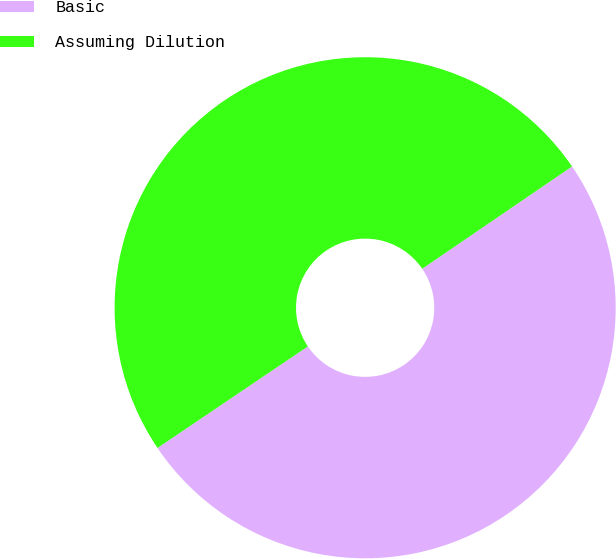Convert chart. <chart><loc_0><loc_0><loc_500><loc_500><pie_chart><fcel>Basic<fcel>Assuming Dilution<nl><fcel>50.08%<fcel>49.92%<nl></chart> 